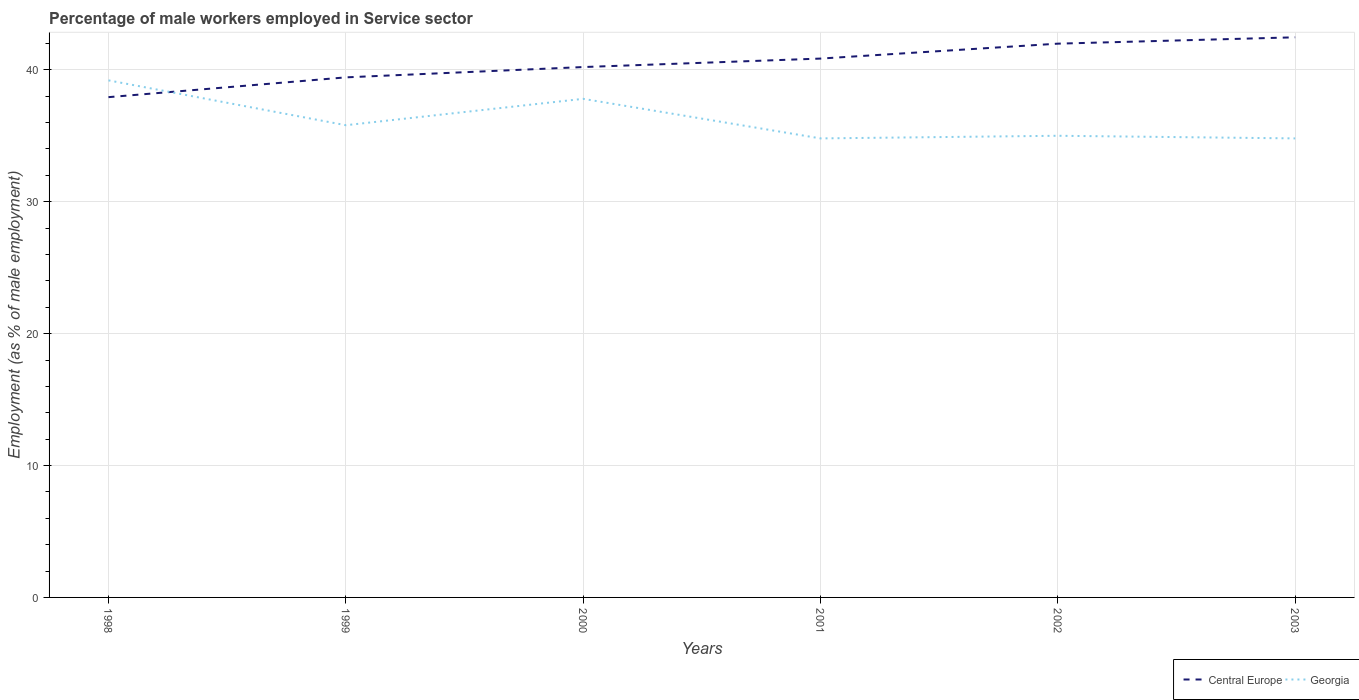Does the line corresponding to Georgia intersect with the line corresponding to Central Europe?
Your response must be concise. Yes. Across all years, what is the maximum percentage of male workers employed in Service sector in Central Europe?
Give a very brief answer. 37.93. In which year was the percentage of male workers employed in Service sector in Georgia maximum?
Offer a very short reply. 2001. What is the total percentage of male workers employed in Service sector in Georgia in the graph?
Give a very brief answer. -0.2. What is the difference between the highest and the second highest percentage of male workers employed in Service sector in Central Europe?
Keep it short and to the point. 4.54. Is the percentage of male workers employed in Service sector in Georgia strictly greater than the percentage of male workers employed in Service sector in Central Europe over the years?
Make the answer very short. No. How many lines are there?
Offer a terse response. 2. How many years are there in the graph?
Your response must be concise. 6. What is the difference between two consecutive major ticks on the Y-axis?
Make the answer very short. 10. Where does the legend appear in the graph?
Your answer should be very brief. Bottom right. How many legend labels are there?
Keep it short and to the point. 2. How are the legend labels stacked?
Ensure brevity in your answer.  Horizontal. What is the title of the graph?
Make the answer very short. Percentage of male workers employed in Service sector. What is the label or title of the Y-axis?
Your response must be concise. Employment (as % of male employment). What is the Employment (as % of male employment) in Central Europe in 1998?
Make the answer very short. 37.93. What is the Employment (as % of male employment) of Georgia in 1998?
Offer a very short reply. 39.2. What is the Employment (as % of male employment) in Central Europe in 1999?
Your response must be concise. 39.43. What is the Employment (as % of male employment) of Georgia in 1999?
Provide a succinct answer. 35.8. What is the Employment (as % of male employment) of Central Europe in 2000?
Your answer should be very brief. 40.21. What is the Employment (as % of male employment) of Georgia in 2000?
Offer a terse response. 37.8. What is the Employment (as % of male employment) in Central Europe in 2001?
Offer a terse response. 40.85. What is the Employment (as % of male employment) of Georgia in 2001?
Give a very brief answer. 34.8. What is the Employment (as % of male employment) of Central Europe in 2002?
Give a very brief answer. 41.98. What is the Employment (as % of male employment) in Central Europe in 2003?
Your answer should be very brief. 42.46. What is the Employment (as % of male employment) in Georgia in 2003?
Your response must be concise. 34.8. Across all years, what is the maximum Employment (as % of male employment) of Central Europe?
Your answer should be very brief. 42.46. Across all years, what is the maximum Employment (as % of male employment) of Georgia?
Your answer should be compact. 39.2. Across all years, what is the minimum Employment (as % of male employment) in Central Europe?
Give a very brief answer. 37.93. Across all years, what is the minimum Employment (as % of male employment) of Georgia?
Your answer should be compact. 34.8. What is the total Employment (as % of male employment) of Central Europe in the graph?
Your answer should be very brief. 242.86. What is the total Employment (as % of male employment) in Georgia in the graph?
Your response must be concise. 217.4. What is the difference between the Employment (as % of male employment) in Central Europe in 1998 and that in 1999?
Your answer should be very brief. -1.5. What is the difference between the Employment (as % of male employment) of Georgia in 1998 and that in 1999?
Your response must be concise. 3.4. What is the difference between the Employment (as % of male employment) in Central Europe in 1998 and that in 2000?
Provide a short and direct response. -2.28. What is the difference between the Employment (as % of male employment) in Georgia in 1998 and that in 2000?
Keep it short and to the point. 1.4. What is the difference between the Employment (as % of male employment) in Central Europe in 1998 and that in 2001?
Give a very brief answer. -2.93. What is the difference between the Employment (as % of male employment) of Central Europe in 1998 and that in 2002?
Provide a short and direct response. -4.06. What is the difference between the Employment (as % of male employment) in Central Europe in 1998 and that in 2003?
Offer a very short reply. -4.54. What is the difference between the Employment (as % of male employment) of Central Europe in 1999 and that in 2000?
Make the answer very short. -0.78. What is the difference between the Employment (as % of male employment) of Central Europe in 1999 and that in 2001?
Provide a succinct answer. -1.42. What is the difference between the Employment (as % of male employment) in Central Europe in 1999 and that in 2002?
Ensure brevity in your answer.  -2.56. What is the difference between the Employment (as % of male employment) in Central Europe in 1999 and that in 2003?
Ensure brevity in your answer.  -3.04. What is the difference between the Employment (as % of male employment) in Central Europe in 2000 and that in 2001?
Make the answer very short. -0.64. What is the difference between the Employment (as % of male employment) of Central Europe in 2000 and that in 2002?
Make the answer very short. -1.77. What is the difference between the Employment (as % of male employment) of Central Europe in 2000 and that in 2003?
Provide a short and direct response. -2.26. What is the difference between the Employment (as % of male employment) in Georgia in 2000 and that in 2003?
Offer a terse response. 3. What is the difference between the Employment (as % of male employment) of Central Europe in 2001 and that in 2002?
Provide a succinct answer. -1.13. What is the difference between the Employment (as % of male employment) in Central Europe in 2001 and that in 2003?
Your response must be concise. -1.61. What is the difference between the Employment (as % of male employment) of Central Europe in 2002 and that in 2003?
Ensure brevity in your answer.  -0.48. What is the difference between the Employment (as % of male employment) of Central Europe in 1998 and the Employment (as % of male employment) of Georgia in 1999?
Your answer should be very brief. 2.13. What is the difference between the Employment (as % of male employment) in Central Europe in 1998 and the Employment (as % of male employment) in Georgia in 2000?
Provide a succinct answer. 0.13. What is the difference between the Employment (as % of male employment) in Central Europe in 1998 and the Employment (as % of male employment) in Georgia in 2001?
Give a very brief answer. 3.13. What is the difference between the Employment (as % of male employment) in Central Europe in 1998 and the Employment (as % of male employment) in Georgia in 2002?
Provide a succinct answer. 2.93. What is the difference between the Employment (as % of male employment) in Central Europe in 1998 and the Employment (as % of male employment) in Georgia in 2003?
Your answer should be very brief. 3.13. What is the difference between the Employment (as % of male employment) in Central Europe in 1999 and the Employment (as % of male employment) in Georgia in 2000?
Provide a succinct answer. 1.63. What is the difference between the Employment (as % of male employment) in Central Europe in 1999 and the Employment (as % of male employment) in Georgia in 2001?
Your response must be concise. 4.63. What is the difference between the Employment (as % of male employment) in Central Europe in 1999 and the Employment (as % of male employment) in Georgia in 2002?
Your answer should be very brief. 4.43. What is the difference between the Employment (as % of male employment) in Central Europe in 1999 and the Employment (as % of male employment) in Georgia in 2003?
Offer a very short reply. 4.63. What is the difference between the Employment (as % of male employment) of Central Europe in 2000 and the Employment (as % of male employment) of Georgia in 2001?
Keep it short and to the point. 5.41. What is the difference between the Employment (as % of male employment) in Central Europe in 2000 and the Employment (as % of male employment) in Georgia in 2002?
Provide a succinct answer. 5.21. What is the difference between the Employment (as % of male employment) in Central Europe in 2000 and the Employment (as % of male employment) in Georgia in 2003?
Your response must be concise. 5.41. What is the difference between the Employment (as % of male employment) of Central Europe in 2001 and the Employment (as % of male employment) of Georgia in 2002?
Your answer should be very brief. 5.85. What is the difference between the Employment (as % of male employment) in Central Europe in 2001 and the Employment (as % of male employment) in Georgia in 2003?
Ensure brevity in your answer.  6.05. What is the difference between the Employment (as % of male employment) of Central Europe in 2002 and the Employment (as % of male employment) of Georgia in 2003?
Make the answer very short. 7.18. What is the average Employment (as % of male employment) of Central Europe per year?
Ensure brevity in your answer.  40.48. What is the average Employment (as % of male employment) in Georgia per year?
Provide a short and direct response. 36.23. In the year 1998, what is the difference between the Employment (as % of male employment) in Central Europe and Employment (as % of male employment) in Georgia?
Your answer should be compact. -1.27. In the year 1999, what is the difference between the Employment (as % of male employment) of Central Europe and Employment (as % of male employment) of Georgia?
Your response must be concise. 3.63. In the year 2000, what is the difference between the Employment (as % of male employment) in Central Europe and Employment (as % of male employment) in Georgia?
Your answer should be compact. 2.41. In the year 2001, what is the difference between the Employment (as % of male employment) in Central Europe and Employment (as % of male employment) in Georgia?
Ensure brevity in your answer.  6.05. In the year 2002, what is the difference between the Employment (as % of male employment) in Central Europe and Employment (as % of male employment) in Georgia?
Provide a short and direct response. 6.98. In the year 2003, what is the difference between the Employment (as % of male employment) of Central Europe and Employment (as % of male employment) of Georgia?
Offer a terse response. 7.66. What is the ratio of the Employment (as % of male employment) of Central Europe in 1998 to that in 1999?
Make the answer very short. 0.96. What is the ratio of the Employment (as % of male employment) of Georgia in 1998 to that in 1999?
Offer a terse response. 1.09. What is the ratio of the Employment (as % of male employment) of Central Europe in 1998 to that in 2000?
Make the answer very short. 0.94. What is the ratio of the Employment (as % of male employment) in Georgia in 1998 to that in 2000?
Provide a short and direct response. 1.04. What is the ratio of the Employment (as % of male employment) of Central Europe in 1998 to that in 2001?
Give a very brief answer. 0.93. What is the ratio of the Employment (as % of male employment) of Georgia in 1998 to that in 2001?
Keep it short and to the point. 1.13. What is the ratio of the Employment (as % of male employment) in Central Europe in 1998 to that in 2002?
Your answer should be compact. 0.9. What is the ratio of the Employment (as % of male employment) of Georgia in 1998 to that in 2002?
Your response must be concise. 1.12. What is the ratio of the Employment (as % of male employment) of Central Europe in 1998 to that in 2003?
Provide a succinct answer. 0.89. What is the ratio of the Employment (as % of male employment) in Georgia in 1998 to that in 2003?
Keep it short and to the point. 1.13. What is the ratio of the Employment (as % of male employment) in Central Europe in 1999 to that in 2000?
Provide a short and direct response. 0.98. What is the ratio of the Employment (as % of male employment) of Georgia in 1999 to that in 2000?
Your answer should be very brief. 0.95. What is the ratio of the Employment (as % of male employment) in Central Europe in 1999 to that in 2001?
Keep it short and to the point. 0.97. What is the ratio of the Employment (as % of male employment) of Georgia in 1999 to that in 2001?
Your answer should be very brief. 1.03. What is the ratio of the Employment (as % of male employment) in Central Europe in 1999 to that in 2002?
Provide a succinct answer. 0.94. What is the ratio of the Employment (as % of male employment) in Georgia in 1999 to that in 2002?
Ensure brevity in your answer.  1.02. What is the ratio of the Employment (as % of male employment) in Central Europe in 1999 to that in 2003?
Keep it short and to the point. 0.93. What is the ratio of the Employment (as % of male employment) in Georgia in 1999 to that in 2003?
Provide a succinct answer. 1.03. What is the ratio of the Employment (as % of male employment) of Central Europe in 2000 to that in 2001?
Your answer should be compact. 0.98. What is the ratio of the Employment (as % of male employment) in Georgia in 2000 to that in 2001?
Provide a short and direct response. 1.09. What is the ratio of the Employment (as % of male employment) of Central Europe in 2000 to that in 2002?
Your answer should be very brief. 0.96. What is the ratio of the Employment (as % of male employment) in Georgia in 2000 to that in 2002?
Your answer should be very brief. 1.08. What is the ratio of the Employment (as % of male employment) in Central Europe in 2000 to that in 2003?
Provide a succinct answer. 0.95. What is the ratio of the Employment (as % of male employment) of Georgia in 2000 to that in 2003?
Your response must be concise. 1.09. What is the ratio of the Employment (as % of male employment) of Central Europe in 2001 to that in 2002?
Offer a very short reply. 0.97. What is the ratio of the Employment (as % of male employment) of Georgia in 2001 to that in 2002?
Your answer should be compact. 0.99. What is the ratio of the Employment (as % of male employment) of Central Europe in 2001 to that in 2003?
Keep it short and to the point. 0.96. What is the ratio of the Employment (as % of male employment) of Georgia in 2001 to that in 2003?
Provide a short and direct response. 1. What is the ratio of the Employment (as % of male employment) in Central Europe in 2002 to that in 2003?
Keep it short and to the point. 0.99. What is the difference between the highest and the second highest Employment (as % of male employment) in Central Europe?
Your response must be concise. 0.48. What is the difference between the highest and the second highest Employment (as % of male employment) in Georgia?
Your answer should be compact. 1.4. What is the difference between the highest and the lowest Employment (as % of male employment) of Central Europe?
Keep it short and to the point. 4.54. What is the difference between the highest and the lowest Employment (as % of male employment) in Georgia?
Your answer should be compact. 4.4. 